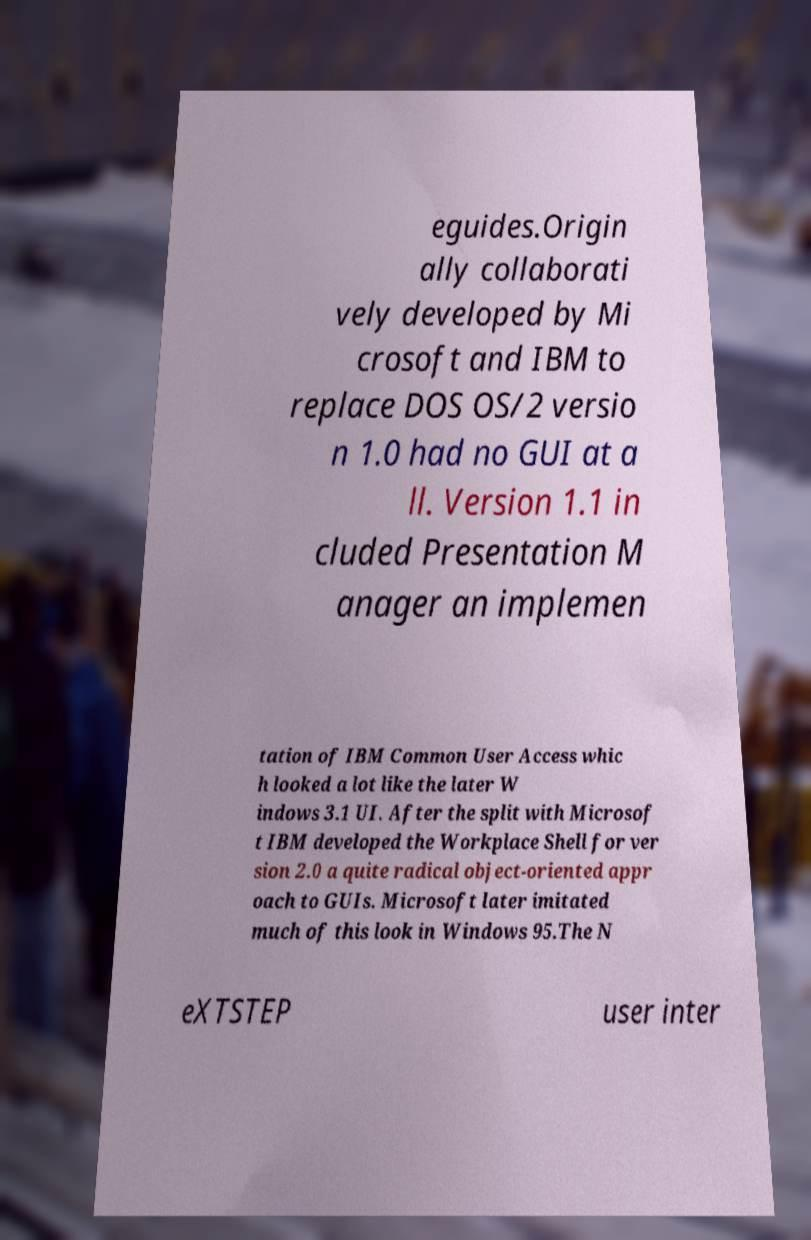I need the written content from this picture converted into text. Can you do that? eguides.Origin ally collaborati vely developed by Mi crosoft and IBM to replace DOS OS/2 versio n 1.0 had no GUI at a ll. Version 1.1 in cluded Presentation M anager an implemen tation of IBM Common User Access whic h looked a lot like the later W indows 3.1 UI. After the split with Microsof t IBM developed the Workplace Shell for ver sion 2.0 a quite radical object-oriented appr oach to GUIs. Microsoft later imitated much of this look in Windows 95.The N eXTSTEP user inter 